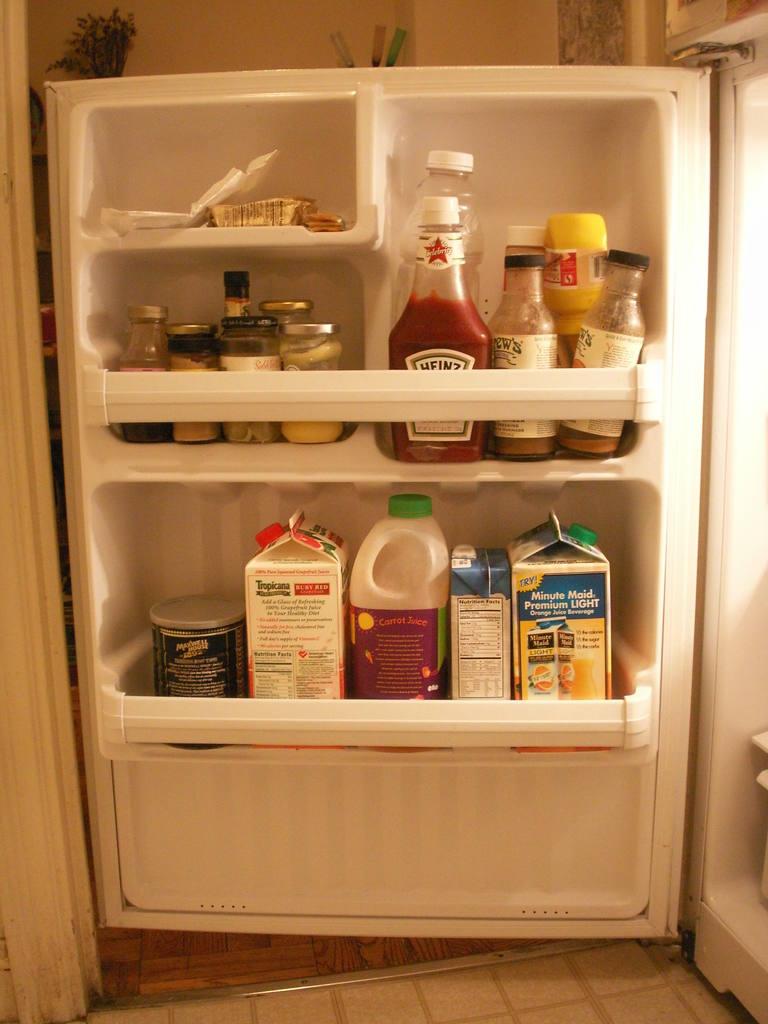What is the brand name of the ketchup?
Give a very brief answer. Heinz. Is there ketchup in the fridge?
Keep it short and to the point. Yes. 